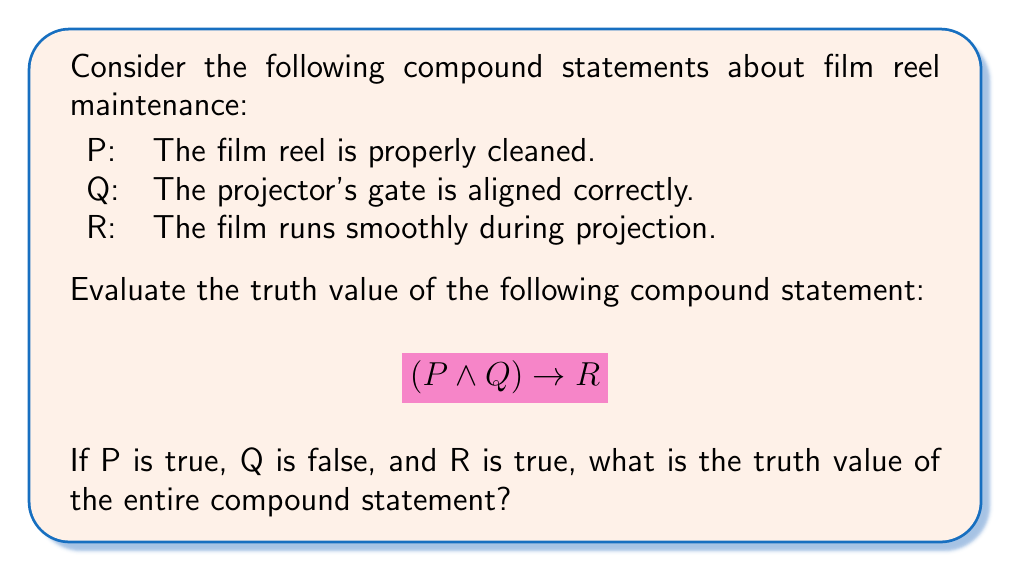Help me with this question. Let's approach this step-by-step:

1) First, we need to understand the logical operators:
   $\wedge$ represents AND
   $\rightarrow$ represents IMPLIES

2) We're given the following truth values:
   P: true
   Q: false
   R: true

3) Let's evaluate the compound statement from left to right:

   a) First, we evaluate $(P \wedge Q)$:
      - $P \wedge Q$ is true only when both P and Q are true
      - Here, P is true but Q is false
      - Therefore, $(P \wedge Q)$ is false

   b) Now we have: false $\rightarrow$ R

4) For the implication operator ($\rightarrow$), we need to remember its truth table:

   $$
   \begin{array}{|c|c|c|}
   \hline
   P & Q & P \rightarrow Q \\
   \hline
   T & T & T \\
   T & F & F \\
   F & T & T \\
   F & F & T \\
   \hline
   \end{array}
   $$

5) In our case, we have false $\rightarrow$ true

6) Looking at the truth table, when the left side of the implication is false and the right side is true, the entire implication is true.

Therefore, the entire compound statement $(P \wedge Q) \rightarrow R$ is true.
Answer: True 